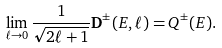Convert formula to latex. <formula><loc_0><loc_0><loc_500><loc_500>\lim _ { \ell \rightarrow 0 } \frac { 1 } { \sqrt { 2 \ell + 1 } } { \mathbf D } ^ { \pm } ( E , \ell ) = Q ^ { \pm } ( E ) .</formula> 